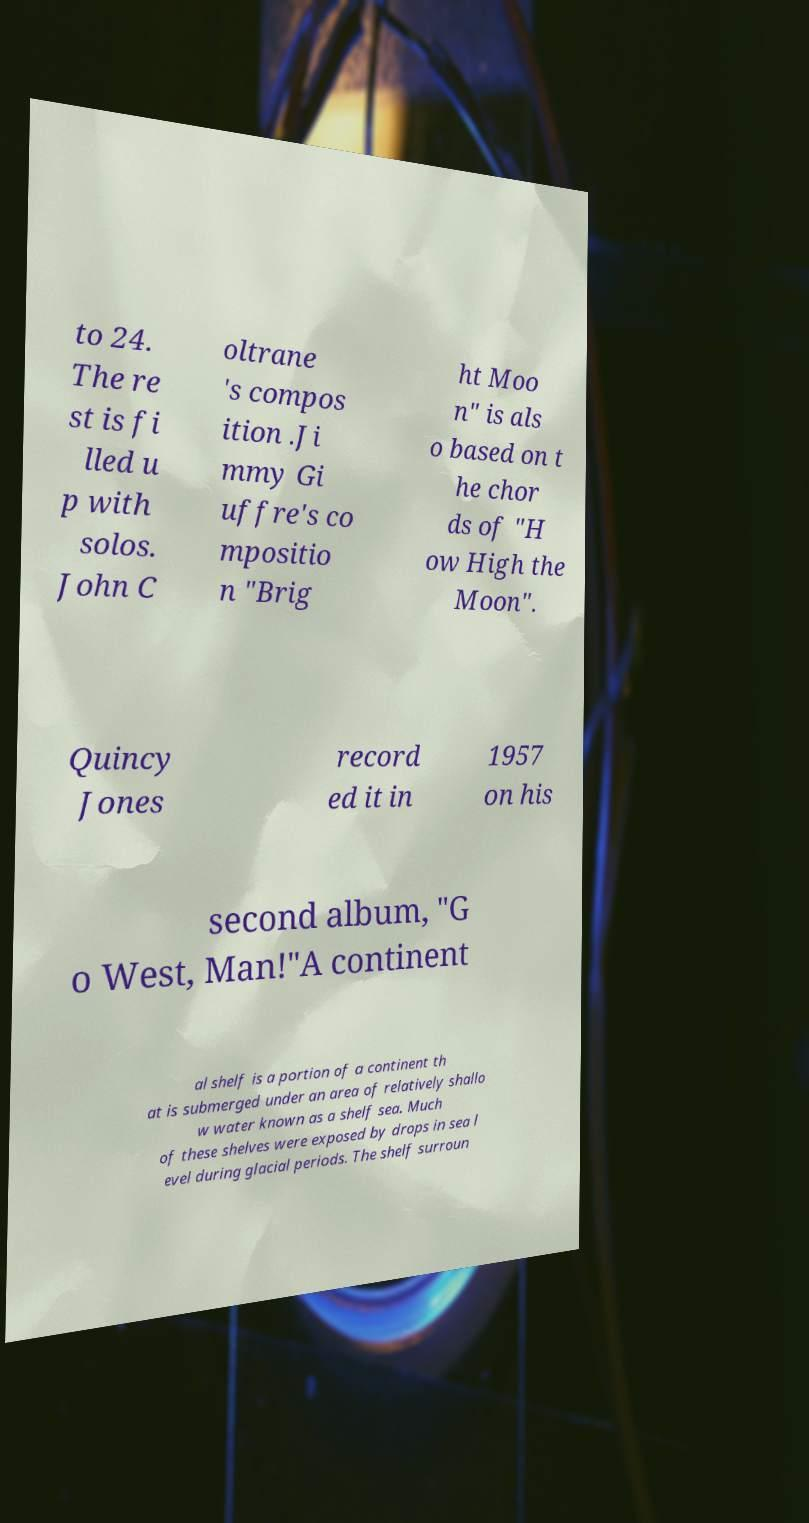Could you extract and type out the text from this image? to 24. The re st is fi lled u p with solos. John C oltrane 's compos ition .Ji mmy Gi uffre's co mpositio n "Brig ht Moo n" is als o based on t he chor ds of "H ow High the Moon". Quincy Jones record ed it in 1957 on his second album, "G o West, Man!"A continent al shelf is a portion of a continent th at is submerged under an area of relatively shallo w water known as a shelf sea. Much of these shelves were exposed by drops in sea l evel during glacial periods. The shelf surroun 